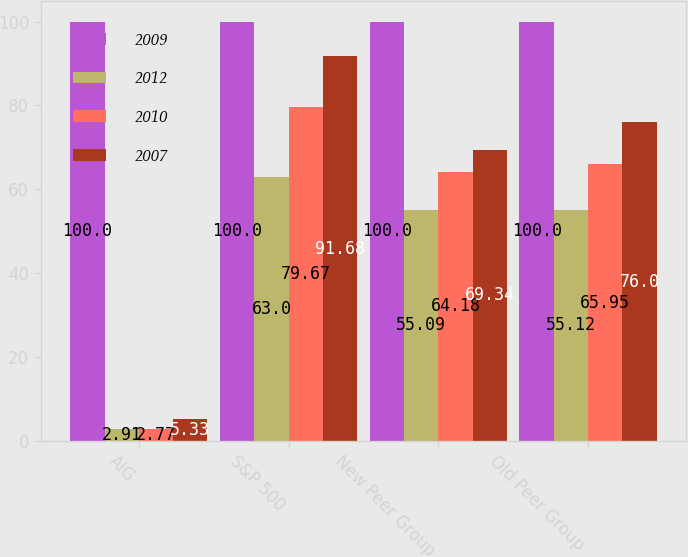Convert chart. <chart><loc_0><loc_0><loc_500><loc_500><stacked_bar_chart><ecel><fcel>AIG<fcel>S&P 500<fcel>New Peer Group<fcel>Old Peer Group<nl><fcel>2009<fcel>100<fcel>100<fcel>100<fcel>100<nl><fcel>2012<fcel>2.91<fcel>63<fcel>55.09<fcel>55.12<nl><fcel>2010<fcel>2.77<fcel>79.67<fcel>64.18<fcel>65.95<nl><fcel>2007<fcel>5.33<fcel>91.68<fcel>69.34<fcel>76<nl></chart> 